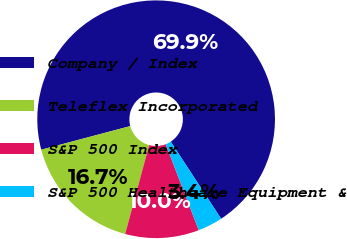Convert chart to OTSL. <chart><loc_0><loc_0><loc_500><loc_500><pie_chart><fcel>Company / Index<fcel>Teleflex Incorporated<fcel>S&P 500 Index<fcel>S&P 500 Healthcare Equipment &<nl><fcel>69.92%<fcel>16.68%<fcel>10.03%<fcel>3.37%<nl></chart> 